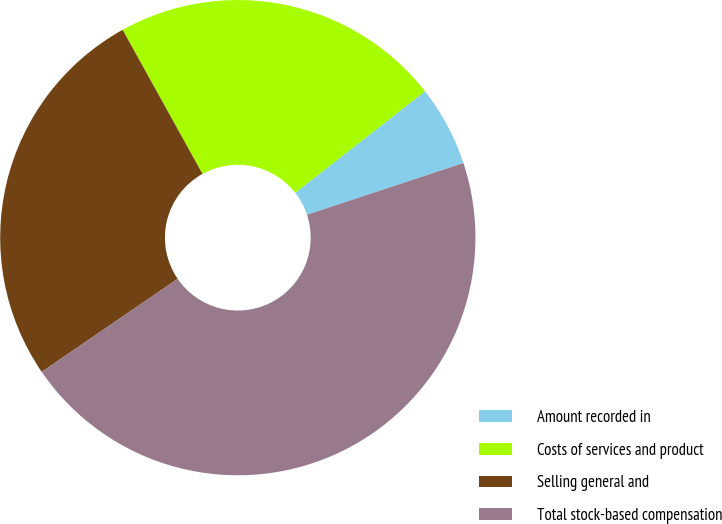<chart> <loc_0><loc_0><loc_500><loc_500><pie_chart><fcel>Amount recorded in<fcel>Costs of services and product<fcel>Selling general and<fcel>Total stock-based compensation<nl><fcel>5.48%<fcel>22.49%<fcel>26.5%<fcel>45.53%<nl></chart> 